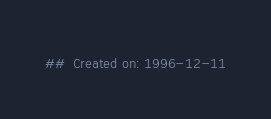Convert code to text. <code><loc_0><loc_0><loc_500><loc_500><_Nim_>##  Created on: 1996-12-11</code> 